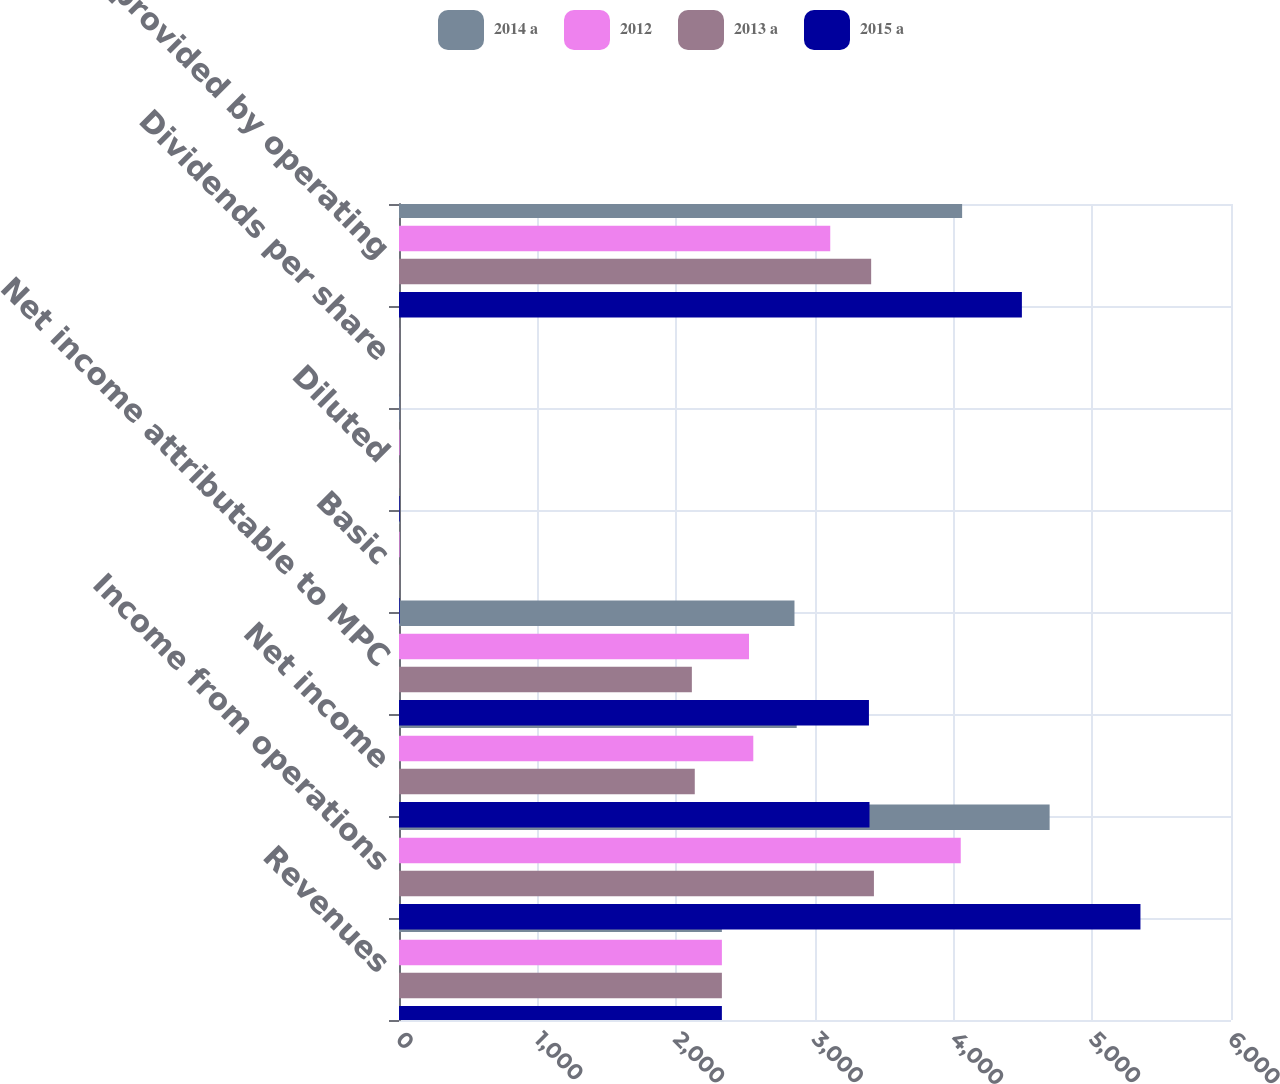Convert chart to OTSL. <chart><loc_0><loc_0><loc_500><loc_500><stacked_bar_chart><ecel><fcel>Revenues<fcel>Income from operations<fcel>Net income<fcel>Net income attributable to MPC<fcel>Basic<fcel>Diluted<fcel>Dividends per share<fcel>Net cash provided by operating<nl><fcel>2014 a<fcel>2328.5<fcel>4692<fcel>2868<fcel>2852<fcel>5.29<fcel>5.26<fcel>1.14<fcel>4061<nl><fcel>2012<fcel>2328.5<fcel>4051<fcel>2555<fcel>2524<fcel>4.42<fcel>4.39<fcel>0.92<fcel>3110<nl><fcel>2013 a<fcel>2328.5<fcel>3425<fcel>2133<fcel>2112<fcel>3.34<fcel>3.32<fcel>0.77<fcel>3405<nl><fcel>2015 a<fcel>2328.5<fcel>5347<fcel>3393<fcel>3389<fcel>4.97<fcel>4.95<fcel>0.6<fcel>4492<nl></chart> 